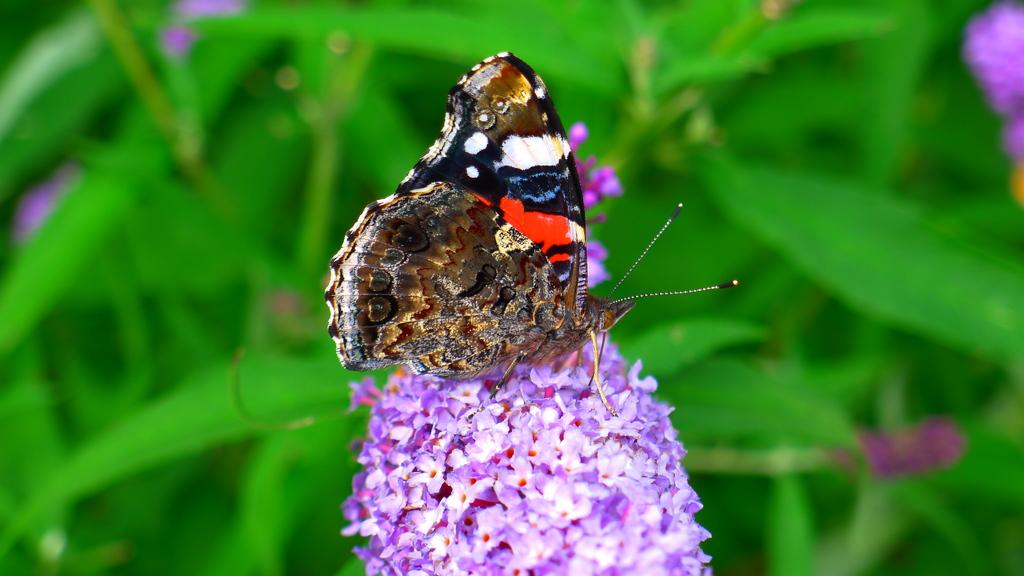What is on the flowers in the image? There is a butterfly on the flowers in the image. How would you describe the appearance of the background in the image? The background of the image is blurred. What celestial bodies can be seen in the background of the image? Planets are visible in the background of the image. What color are the flowers that the butterfly is on? Pink color flowers are present in the image. What type of floor can be seen in the image? There is no floor visible in the image; it primarily features flowers, a butterfly, and planets in the background. 